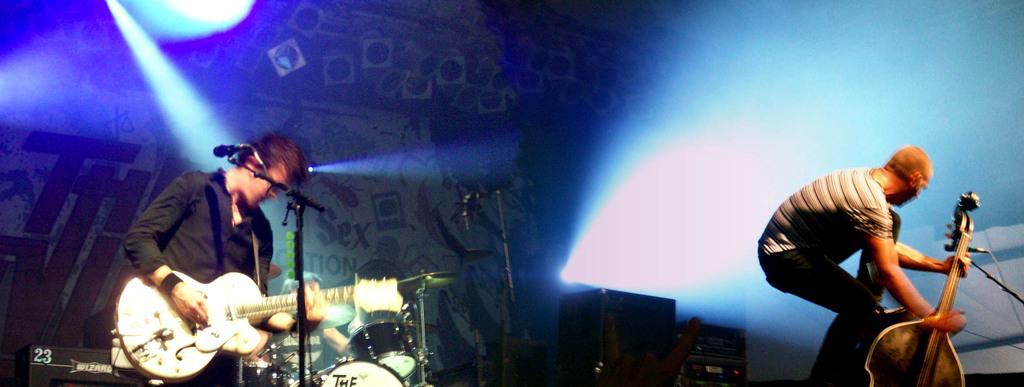Can you describe this image briefly? In this image there is a man standing and playing a guitar near the micro phone , another man standing and holding a guitar ,and at the back ground there is a man sitting and playing the drums , focus lights, speakers. 